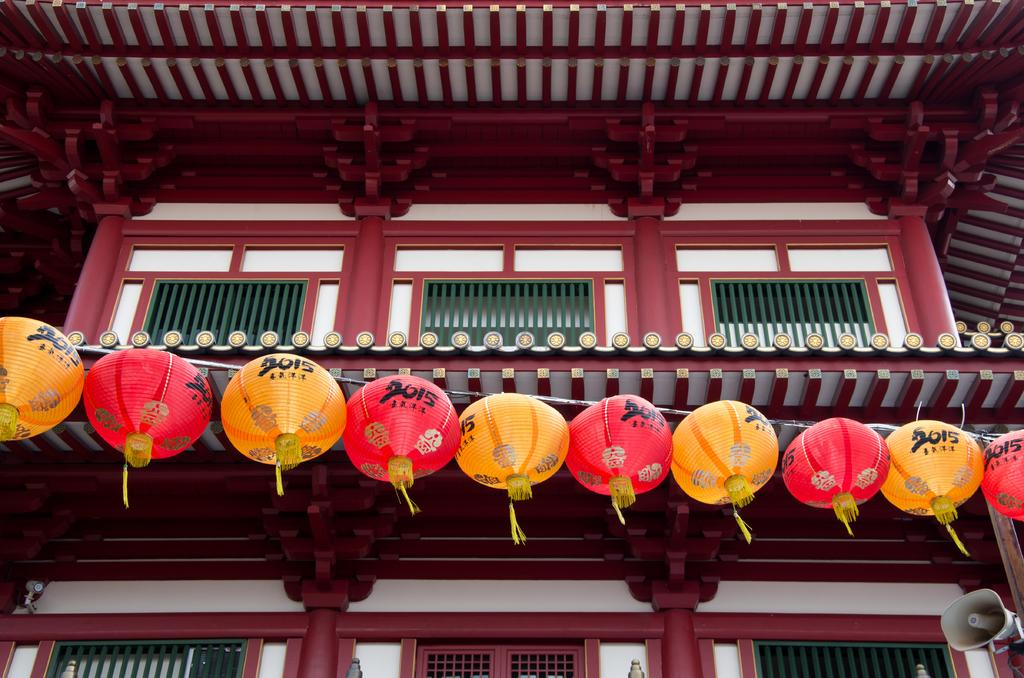<image>
Offer a succinct explanation of the picture presented. A line of orange and red lanterns signify that the year is 2015. 